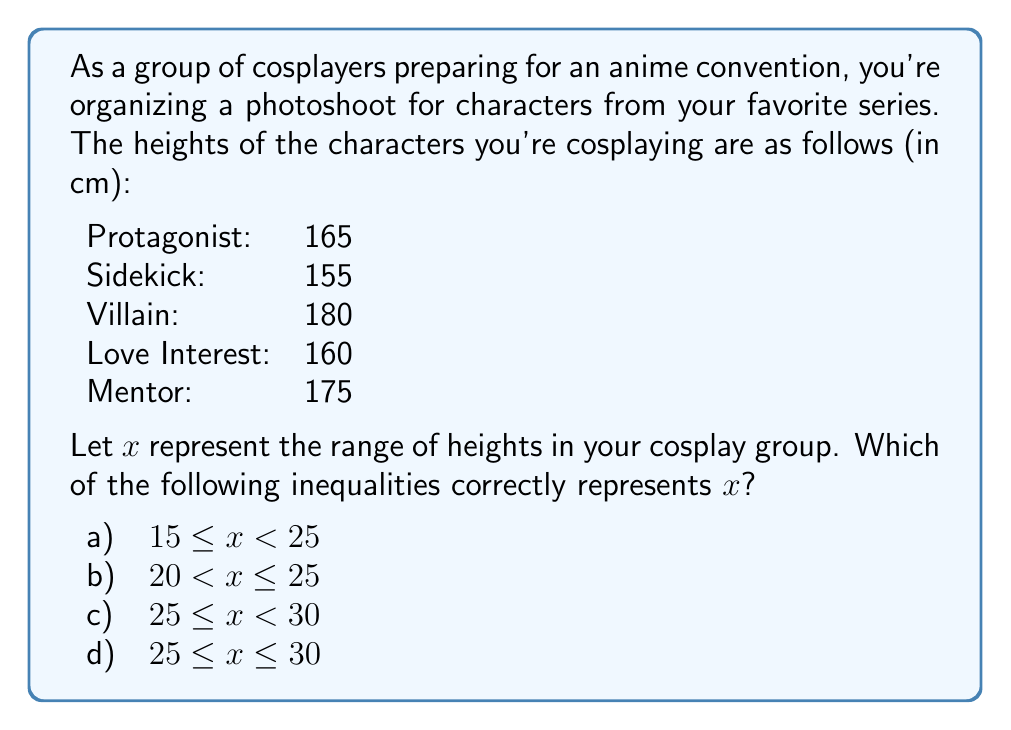Teach me how to tackle this problem. To solve this problem, we need to follow these steps:

1) First, let's recall the definition of range:
   Range = Maximum value - Minimum value

2) Identify the maximum and minimum heights:
   Maximum height: 180 cm (Villain)
   Minimum height: 155 cm (Sidekick)

3) Calculate the range:
   $$x = 180 - 155 = 25\text{ cm}$$

4) Now, we need to find which inequality correctly represents this value.

   a) $15 \leq x < 25$ : This is incorrect as $x = 25$, which is not less than 25.
   b) $20 < x \leq 25$ : This is correct as 25 is greater than 20 and equal to 25.
   c) $25 \leq x < 30$ : This is incorrect as $x$ is not strictly less than 30.
   d) $25 \leq x \leq 30$ : This is also correct as 25 is equal to 25 and less than 30.

5) Both b) and d) are mathematically correct. However, in the context of this problem, b) is the most precise representation as it gives the exact upper bound.
Answer: b) $20 < x \leq 25$ 